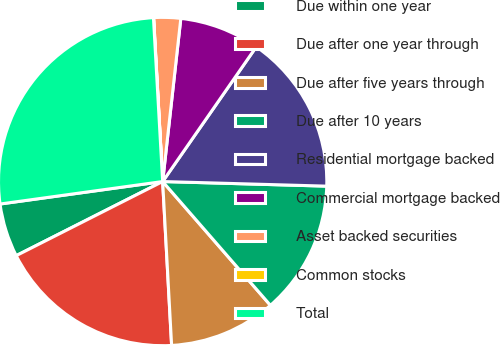<chart> <loc_0><loc_0><loc_500><loc_500><pie_chart><fcel>Due within one year<fcel>Due after one year through<fcel>Due after five years through<fcel>Due after 10 years<fcel>Residential mortgage backed<fcel>Commercial mortgage backed<fcel>Asset backed securities<fcel>Common stocks<fcel>Total<nl><fcel>5.27%<fcel>18.41%<fcel>10.53%<fcel>13.15%<fcel>15.78%<fcel>7.9%<fcel>2.64%<fcel>0.02%<fcel>26.29%<nl></chart> 